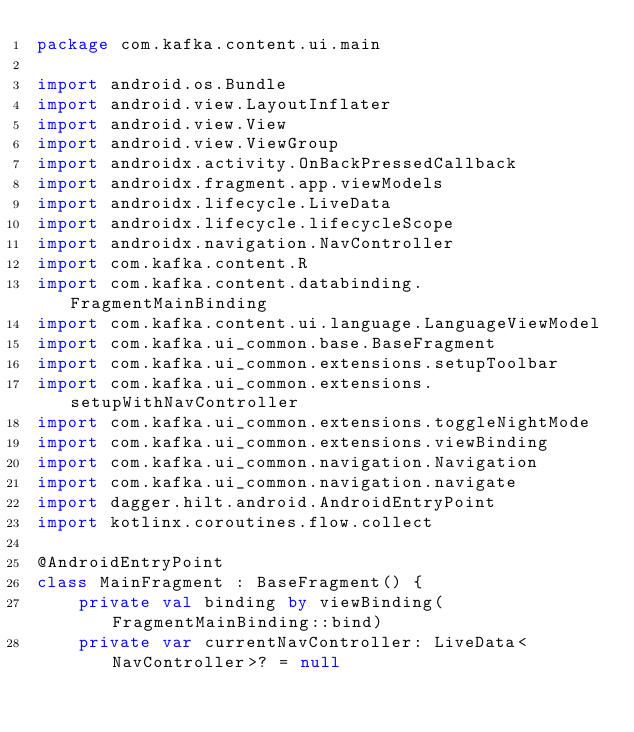<code> <loc_0><loc_0><loc_500><loc_500><_Kotlin_>package com.kafka.content.ui.main

import android.os.Bundle
import android.view.LayoutInflater
import android.view.View
import android.view.ViewGroup
import androidx.activity.OnBackPressedCallback
import androidx.fragment.app.viewModels
import androidx.lifecycle.LiveData
import androidx.lifecycle.lifecycleScope
import androidx.navigation.NavController
import com.kafka.content.R
import com.kafka.content.databinding.FragmentMainBinding
import com.kafka.content.ui.language.LanguageViewModel
import com.kafka.ui_common.base.BaseFragment
import com.kafka.ui_common.extensions.setupToolbar
import com.kafka.ui_common.extensions.setupWithNavController
import com.kafka.ui_common.extensions.toggleNightMode
import com.kafka.ui_common.extensions.viewBinding
import com.kafka.ui_common.navigation.Navigation
import com.kafka.ui_common.navigation.navigate
import dagger.hilt.android.AndroidEntryPoint
import kotlinx.coroutines.flow.collect

@AndroidEntryPoint
class MainFragment : BaseFragment() {
    private val binding by viewBinding(FragmentMainBinding::bind)
    private var currentNavController: LiveData<NavController>? = null</code> 